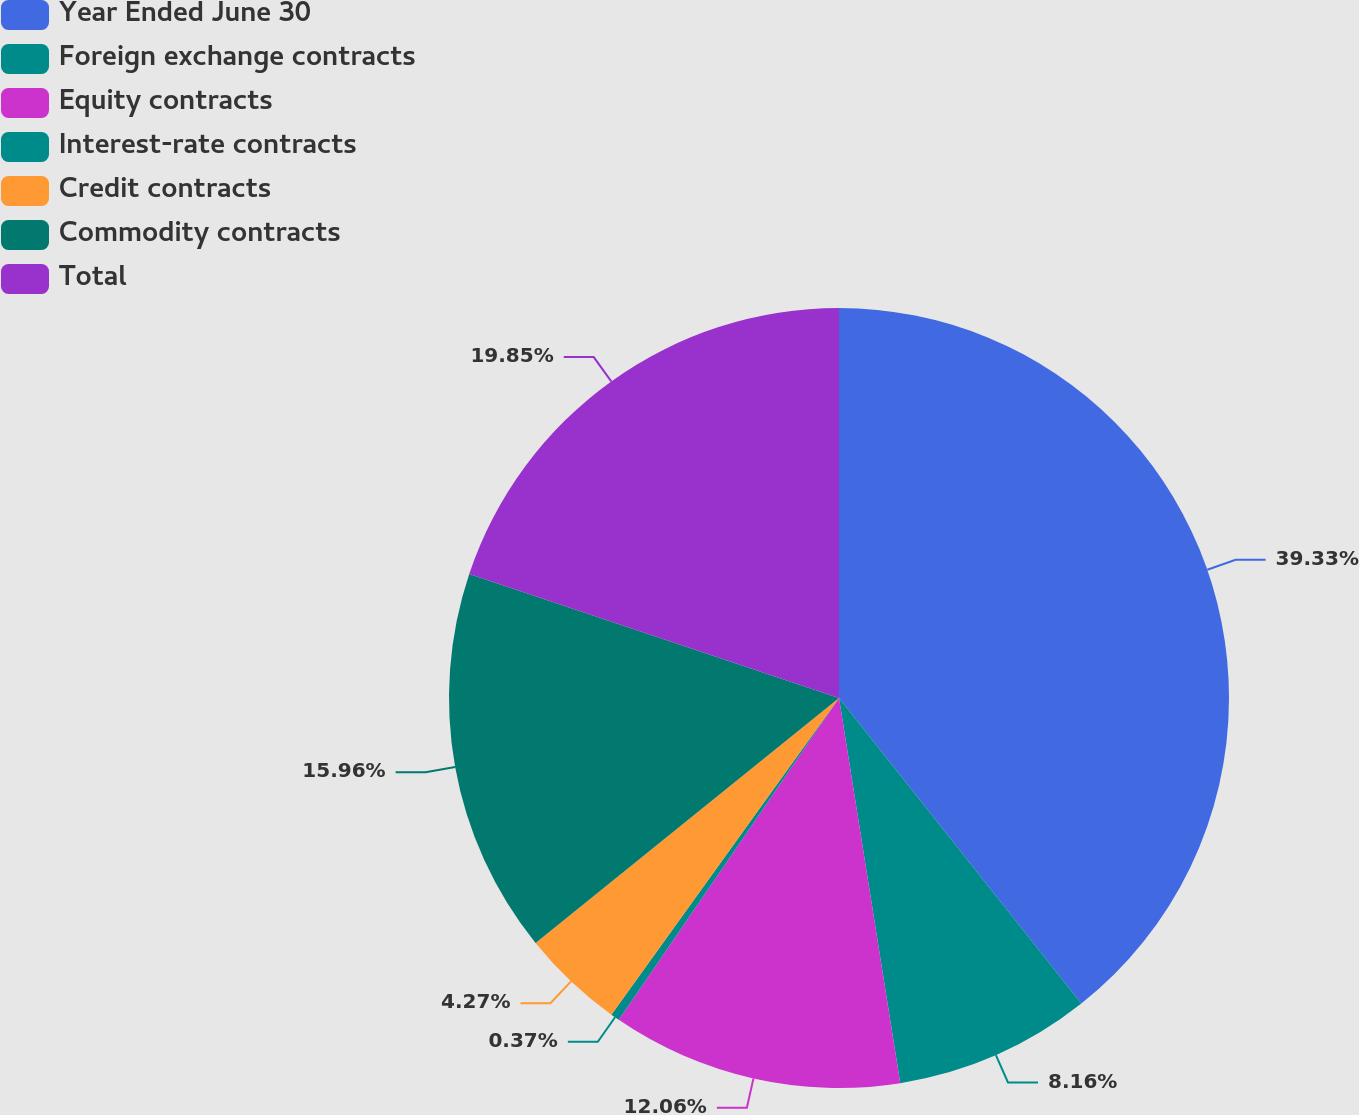Convert chart to OTSL. <chart><loc_0><loc_0><loc_500><loc_500><pie_chart><fcel>Year Ended June 30<fcel>Foreign exchange contracts<fcel>Equity contracts<fcel>Interest-rate contracts<fcel>Credit contracts<fcel>Commodity contracts<fcel>Total<nl><fcel>39.33%<fcel>8.16%<fcel>12.06%<fcel>0.37%<fcel>4.27%<fcel>15.96%<fcel>19.85%<nl></chart> 